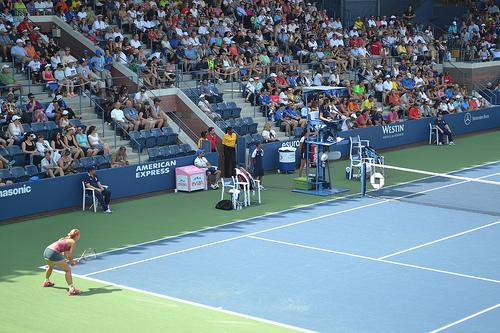Question: what game is being played?
Choices:
A. Football.
B. Soccer.
C. Tennis.
D. Golf.
Answer with the letter. Answer: C Question: how many nets do you see?
Choices:
A. Five.
B. Four.
C. One.
D. Three.
Answer with the letter. Answer: C Question: who are sitting in the stands?
Choices:
A. Parents.
B. The Band.
C. Cheerleaders.
D. Fans.
Answer with the letter. Answer: D Question: who is holding the tennis racket?
Choices:
A. The ball boy.
B. The tennis player.
C. The coach.
D. The players.
Answer with the letter. Answer: B 